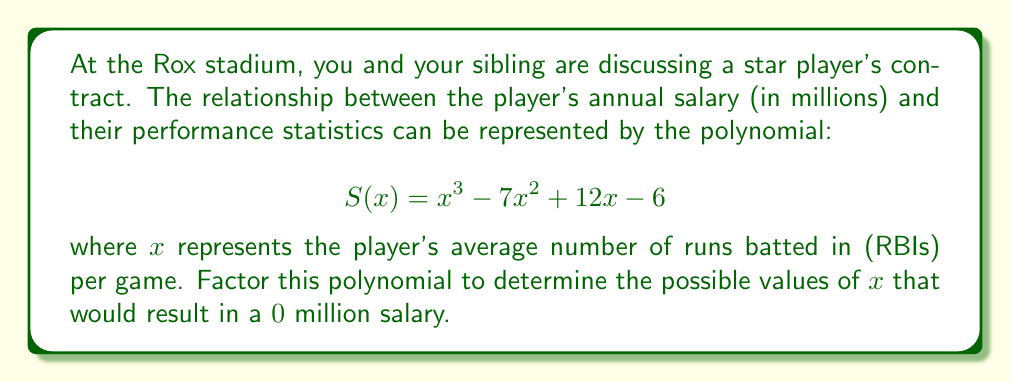Give your solution to this math problem. To factor this polynomial, we'll follow these steps:

1) First, let's check if there are any rational roots using the rational root theorem. The possible rational roots are the factors of the constant term (6): ±1, ±2, ±3, ±6.

2) Testing these values, we find that $x = 1$ is a root of the polynomial. So $(x - 1)$ is a factor.

3) We can use polynomial long division to divide $S(x)$ by $(x - 1)$:

   $$ x^3 - 7x^2 + 12x - 6 = (x - 1)(x^2 - 6x + 6) $$

4) Now we need to factor the quadratic term $x^2 - 6x + 6$. We can do this by finding two numbers that multiply to give 6 and add to give -6. These numbers are -2 and -4.

5) So we can factor $x^2 - 6x + 6$ as $(x - 2)(x - 4)$.

6) Putting it all together, we get:

   $$ S(x) = x^3 - 7x^2 + 12x - 6 = (x - 1)(x - 2)(x - 4) $$

Therefore, the polynomial is factored, and the values of $x$ that would result in a $0 million salary are 1, 2, and 4 RBIs per game.
Answer: $$ S(x) = (x - 1)(x - 2)(x - 4) $$
The values of $x$ that result in a $0 million salary are 1, 2, and 4 RBIs per game. 